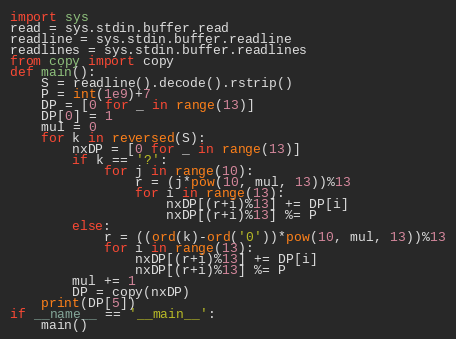<code> <loc_0><loc_0><loc_500><loc_500><_Python_>import sys
read = sys.stdin.buffer.read
readline = sys.stdin.buffer.readline
readlines = sys.stdin.buffer.readlines
from copy import copy 
def main():
    S = readline().decode().rstrip()
    P = int(1e9)+7
    DP = [0 for _ in range(13)]
    DP[0] = 1
    mul = 0
    for k in reversed(S):
        nxDP = [0 for _ in range(13)]
        if k == '?':
            for j in range(10):
                r = (j*pow(10, mul, 13))%13
                for i in range(13):
                    nxDP[(r+i)%13] += DP[i] 
                    nxDP[(r+i)%13] %= P  
        else:
            r = ((ord(k)-ord('0'))*pow(10, mul, 13))%13
            for i in range(13):
                nxDP[(r+i)%13] += DP[i] 
                nxDP[(r+i)%13] %= P
        mul += 1
        DP = copy(nxDP)
    print(DP[5])
if __name__ == '__main__':
    main()</code> 